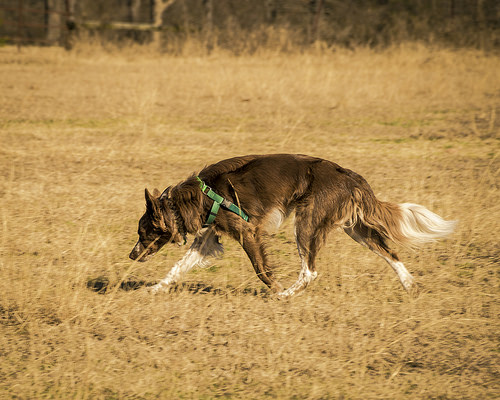<image>
Is there a dog on the grass? Yes. Looking at the image, I can see the dog is positioned on top of the grass, with the grass providing support. 